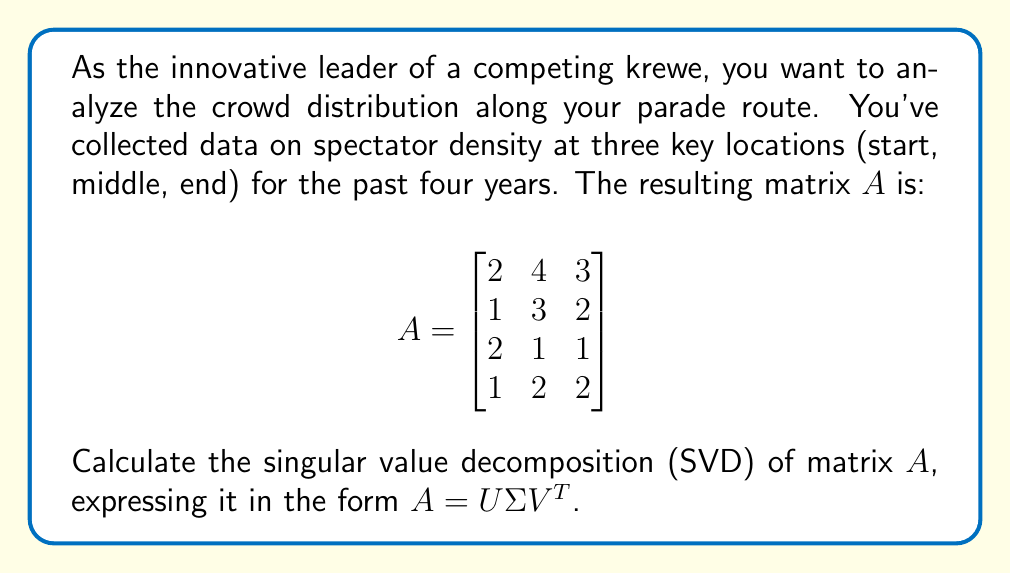Provide a solution to this math problem. To find the SVD of matrix $A$, we'll follow these steps:

1) First, calculate $A^TA$ and $AA^T$:

   $$A^TA = \begin{bmatrix}
   2 & 1 & 2 & 1 \\
   4 & 3 & 1 & 2 \\
   3 & 2 & 1 & 2
   \end{bmatrix} \begin{bmatrix}
   2 & 4 & 3 \\
   1 & 3 & 2 \\
   2 & 1 & 1 \\
   1 & 2 & 2
   \end{bmatrix} = \begin{bmatrix}
   10 & 15 & 12 \\
   15 & 30 & 22 \\
   12 & 22 & 18
   \end{bmatrix}$$

   $$AA^T = \begin{bmatrix}
   2 & 4 & 3 \\
   1 & 3 & 2 \\
   2 & 1 & 1 \\
   1 & 2 & 2
   \end{bmatrix} \begin{bmatrix}
   2 & 1 & 2 & 1 \\
   4 & 3 & 1 & 2 \\
   3 & 2 & 1 & 2
   \end{bmatrix} = \begin{bmatrix}
   29 & 19 & 11 & 16 \\
   19 & 14 & 7 & 11 \\
   11 & 7 & 6 & 6 \\
   16 & 11 & 6 & 9
   \end{bmatrix}$$

2) Find the eigenvalues of $A^TA$:
   Characteristic equation: $det(A^TA - \lambda I) = 0$
   Solving this gives: $\lambda_1 \approx 53.90, \lambda_2 \approx 4.07, \lambda_3 \approx 0.03$

3) The singular values are the square roots of these eigenvalues:
   $\sigma_1 \approx 7.34, \sigma_2 \approx 2.02, \sigma_3 \approx 0.17$

4) Find the right singular vectors (eigenvectors of $A^TA$):
   $v_1 \approx [0.39, 0.73, 0.56]^T$
   $v_2 \approx [-0.72, 0.03, 0.69]^T$
   $v_3 \approx [0.57, -0.68, 0.46]^T$

5) Find the left singular vectors:
   $u_i = \frac{1}{\sigma_i}Av_i$ for $i = 1, 2, 3$
   $u_4$ is in the null space of $A^T$

   $u_1 \approx [0.63, 0.45, 0.32, 0.54]^T$
   $u_2 \approx [-0.34, -0.18, 0.89, -0.25]^T$
   $u_3 \approx [0.21, -0.86, 0.15, 0.44]^T$
   $u_4 \approx [0.67, -0.17, -0.29, -0.67]^T$

6) Construct matrices $U$, $\Sigma$, and $V$:

   $$U \approx \begin{bmatrix}
   0.63 & -0.34 & 0.21 & 0.67 \\
   0.45 & -0.18 & -0.86 & -0.17 \\
   0.32 & 0.89 & 0.15 & -0.29 \\
   0.54 & -0.25 & 0.44 & -0.67
   \end{bmatrix}$$

   $$\Sigma \approx \begin{bmatrix}
   7.34 & 0 & 0 \\
   0 & 2.02 & 0 \\
   0 & 0 & 0.17 \\
   0 & 0 & 0
   \end{bmatrix}$$

   $$V \approx \begin{bmatrix}
   0.39 & -0.72 & 0.57 \\
   0.73 & 0.03 & -0.68 \\
   0.56 & 0.69 & 0.46
   \end{bmatrix}$$

Thus, $A = U\Sigma V^T$.
Answer: $A = U\Sigma V^T$, where:
$$U \approx \begin{bmatrix}
0.63 & -0.34 & 0.21 & 0.67 \\
0.45 & -0.18 & -0.86 & -0.17 \\
0.32 & 0.89 & 0.15 & -0.29 \\
0.54 & -0.25 & 0.44 & -0.67
\end{bmatrix}$$
$$\Sigma \approx \begin{bmatrix}
7.34 & 0 & 0 \\
0 & 2.02 & 0 \\
0 & 0 & 0.17 \\
0 & 0 & 0
\end{bmatrix}$$
$$V \approx \begin{bmatrix}
0.39 & -0.72 & 0.57 \\
0.73 & 0.03 & -0.68 \\
0.56 & 0.69 & 0.46
\end{bmatrix}$$ 